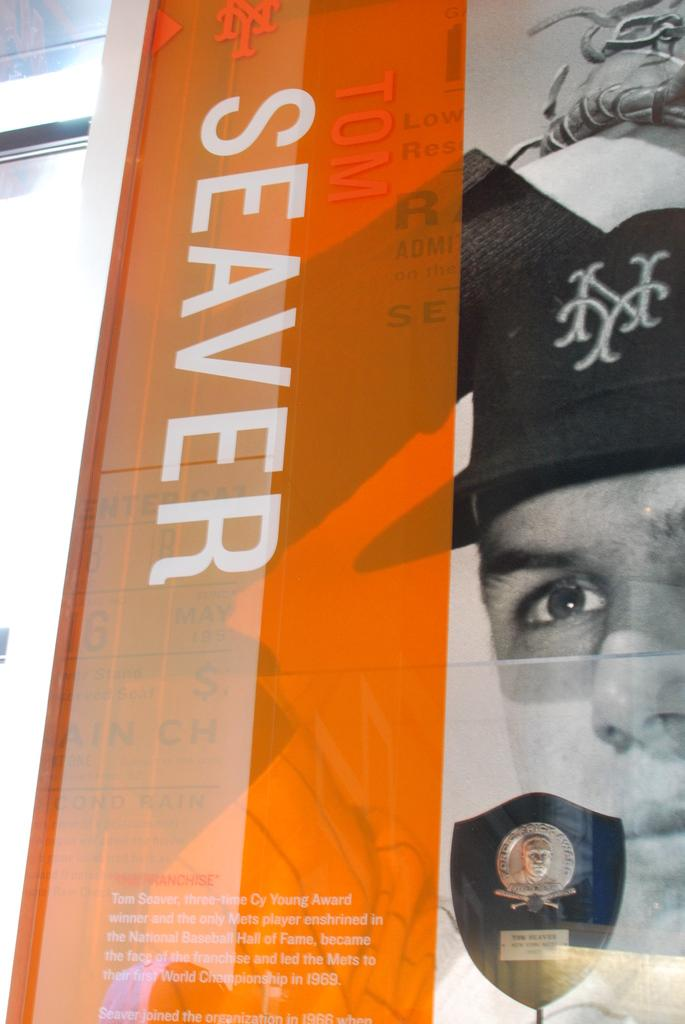What is the main object in the image? There is a poster in the image. What can be seen in the middle of the poster? The poster has text in the middle. What is on the right side of the poster? There is a man's photo on the right side of the poster. What is visible behind the poster? There appears to be a wall behind the poster. How many dogs are present in the image? There are no dogs present in the image. What type of hat is the man wearing in the image? There is no man wearing a hat in the image, as the man's photo only shows his face. 